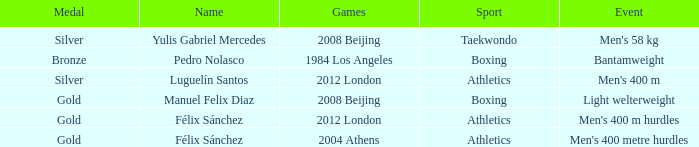Which Sport had an Event of men's 400 m hurdles? Athletics. 